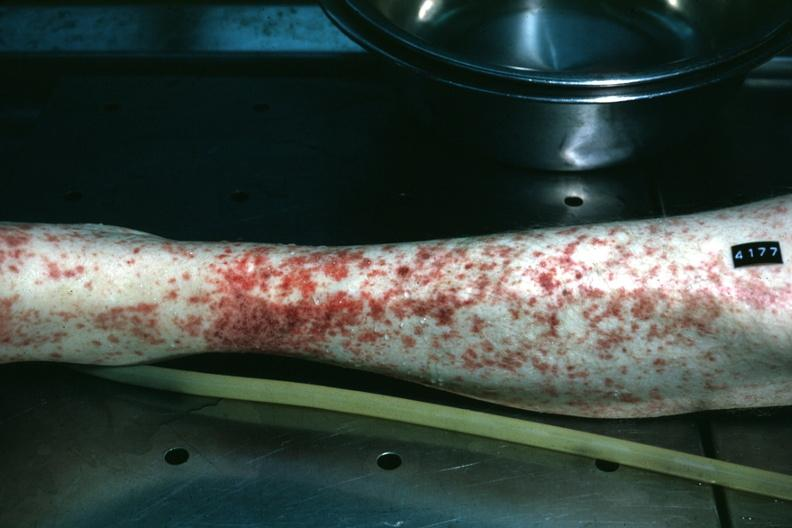s penis, testicles present?
Answer the question using a single word or phrase. No 